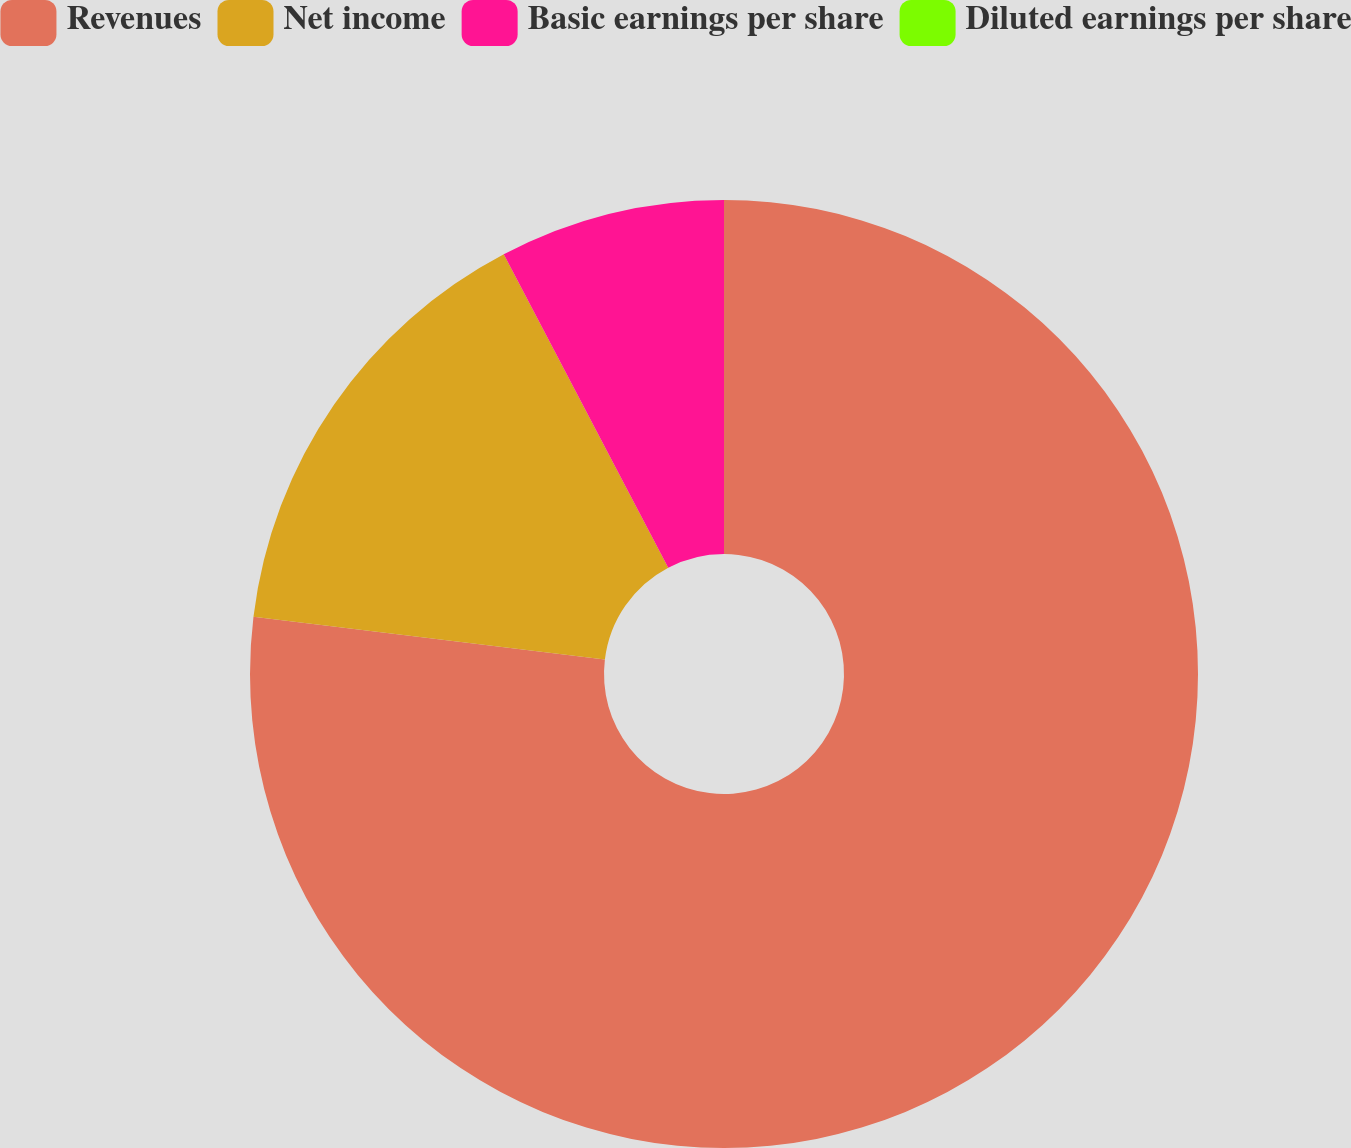<chart> <loc_0><loc_0><loc_500><loc_500><pie_chart><fcel>Revenues<fcel>Net income<fcel>Basic earnings per share<fcel>Diluted earnings per share<nl><fcel>76.92%<fcel>15.38%<fcel>7.69%<fcel>0.0%<nl></chart> 